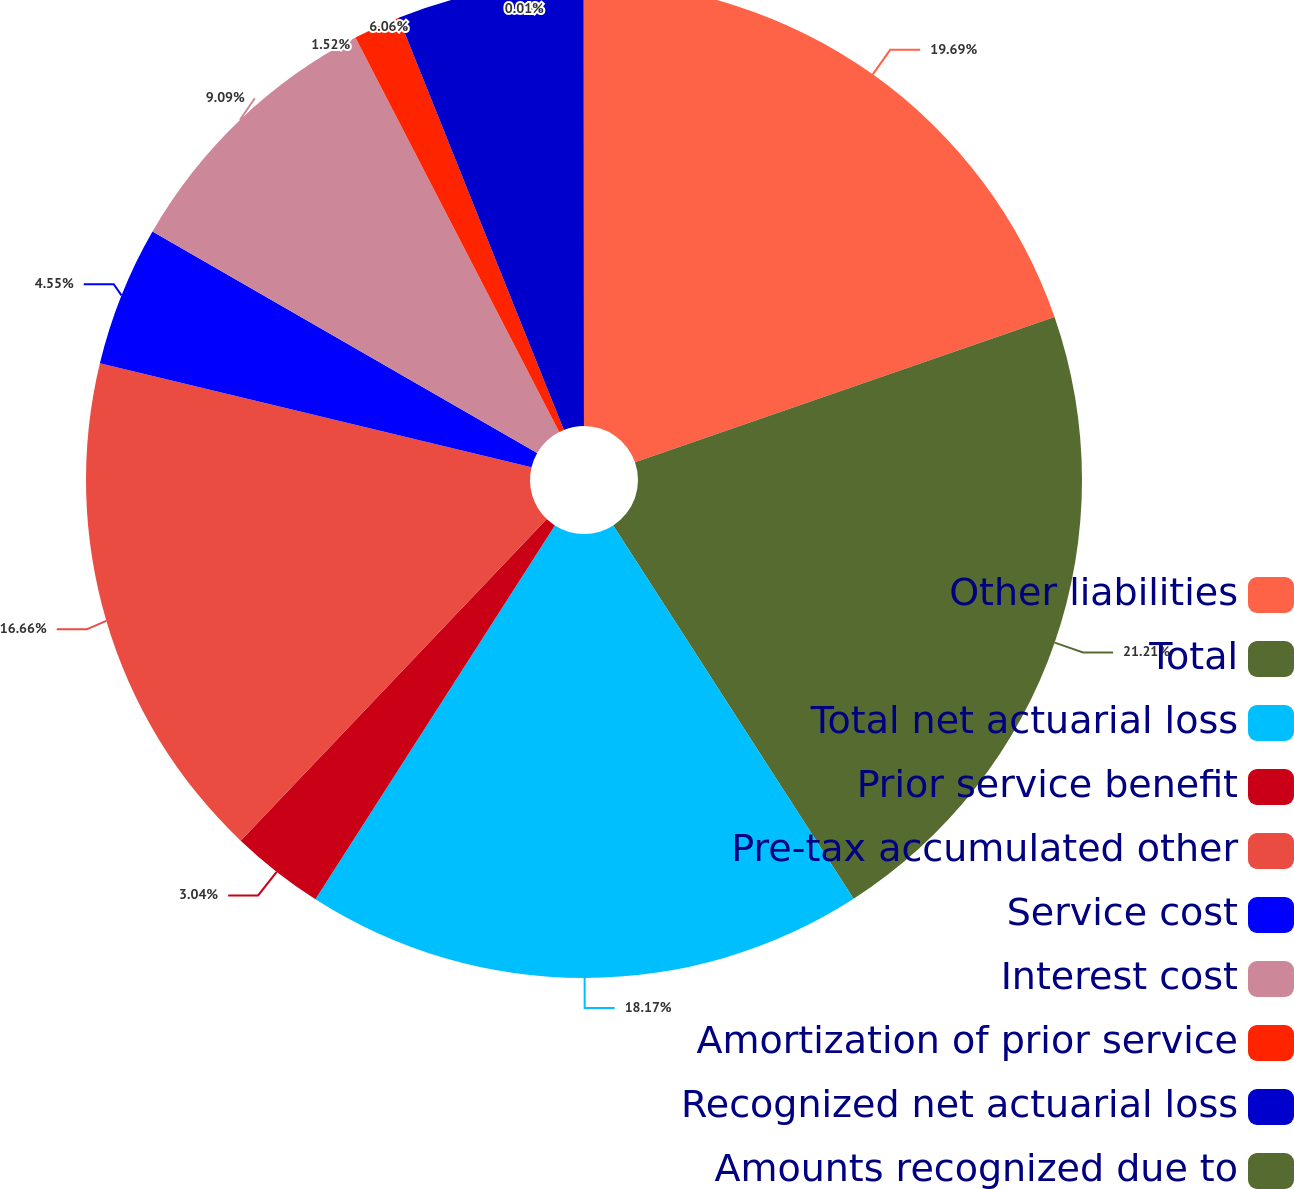<chart> <loc_0><loc_0><loc_500><loc_500><pie_chart><fcel>Other liabilities<fcel>Total<fcel>Total net actuarial loss<fcel>Prior service benefit<fcel>Pre-tax accumulated other<fcel>Service cost<fcel>Interest cost<fcel>Amortization of prior service<fcel>Recognized net actuarial loss<fcel>Amounts recognized due to<nl><fcel>19.69%<fcel>21.2%<fcel>18.17%<fcel>3.04%<fcel>16.66%<fcel>4.55%<fcel>9.09%<fcel>1.52%<fcel>6.06%<fcel>0.01%<nl></chart> 